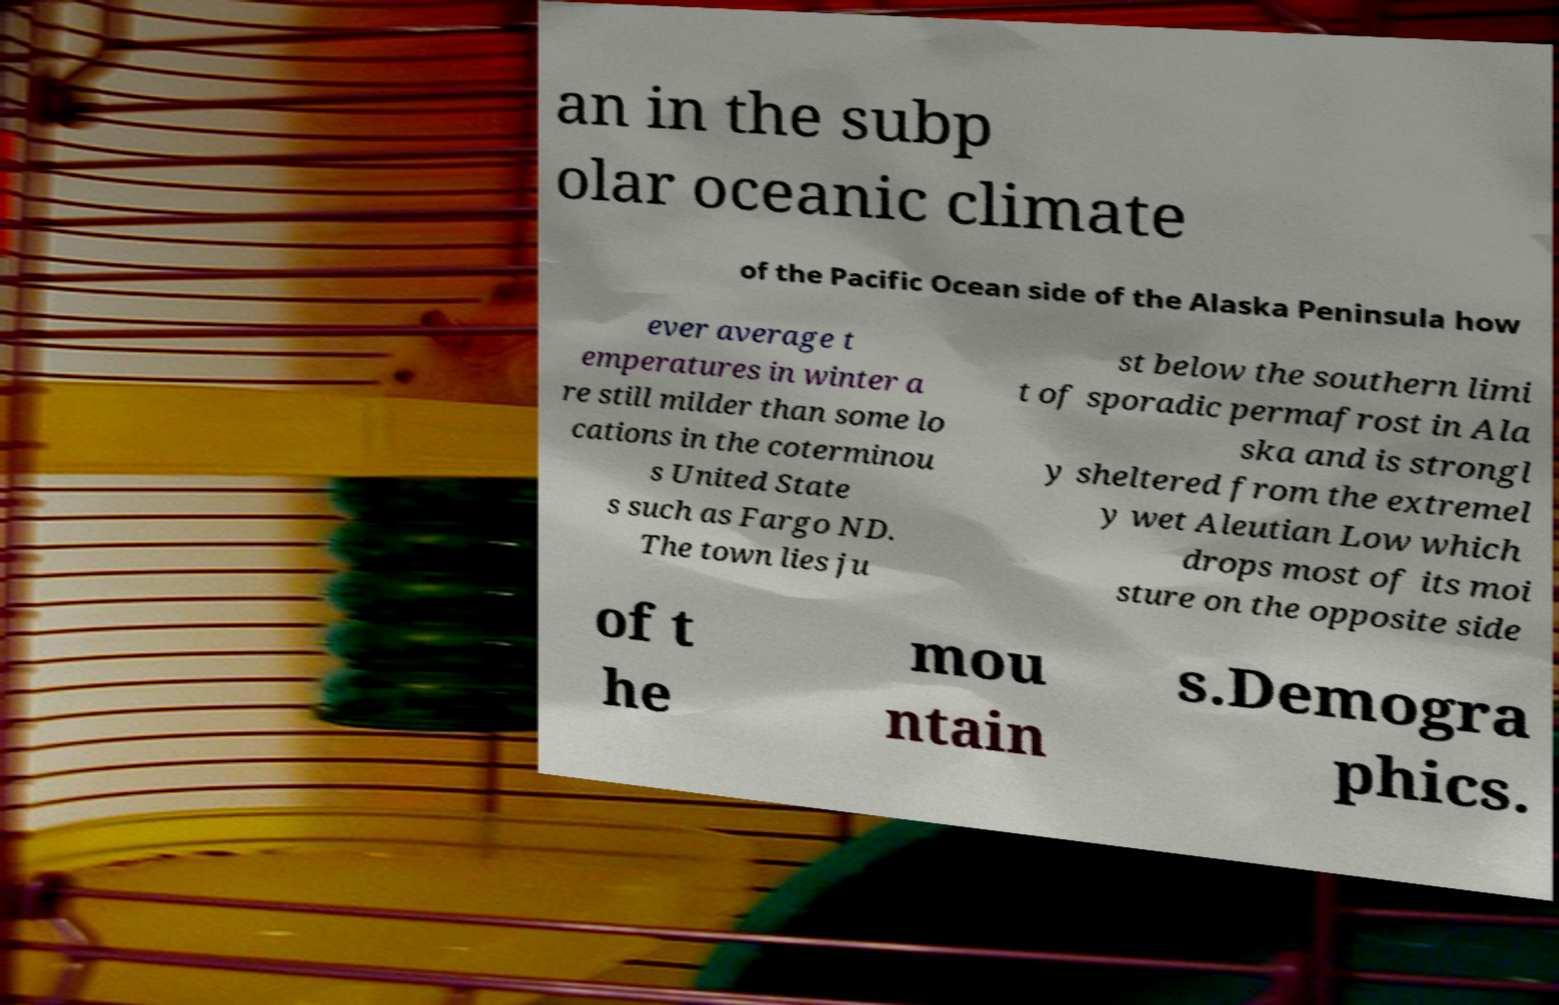Can you read and provide the text displayed in the image?This photo seems to have some interesting text. Can you extract and type it out for me? an in the subp olar oceanic climate of the Pacific Ocean side of the Alaska Peninsula how ever average t emperatures in winter a re still milder than some lo cations in the coterminou s United State s such as Fargo ND. The town lies ju st below the southern limi t of sporadic permafrost in Ala ska and is strongl y sheltered from the extremel y wet Aleutian Low which drops most of its moi sture on the opposite side of t he mou ntain s.Demogra phics. 